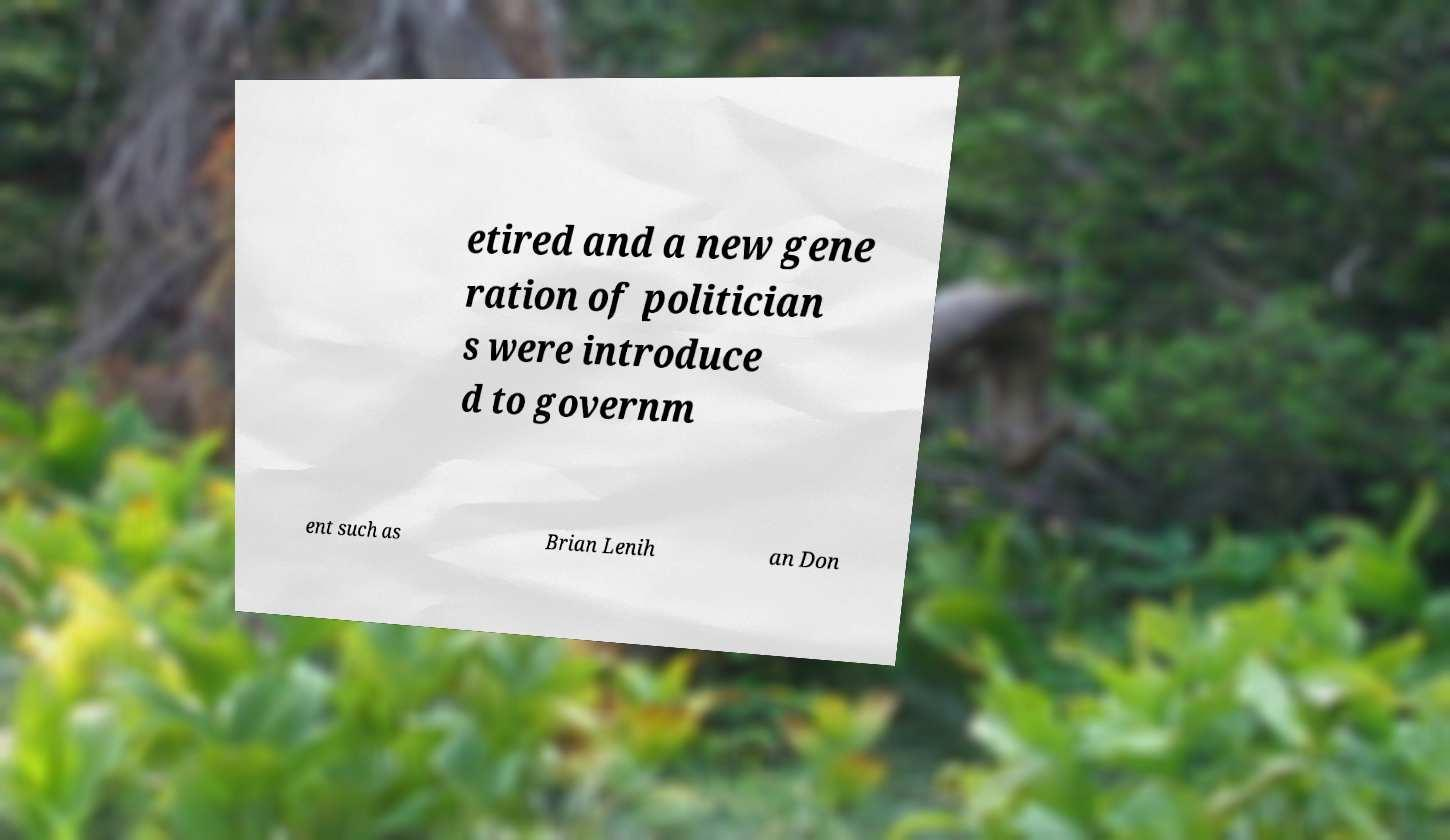Can you read and provide the text displayed in the image?This photo seems to have some interesting text. Can you extract and type it out for me? etired and a new gene ration of politician s were introduce d to governm ent such as Brian Lenih an Don 